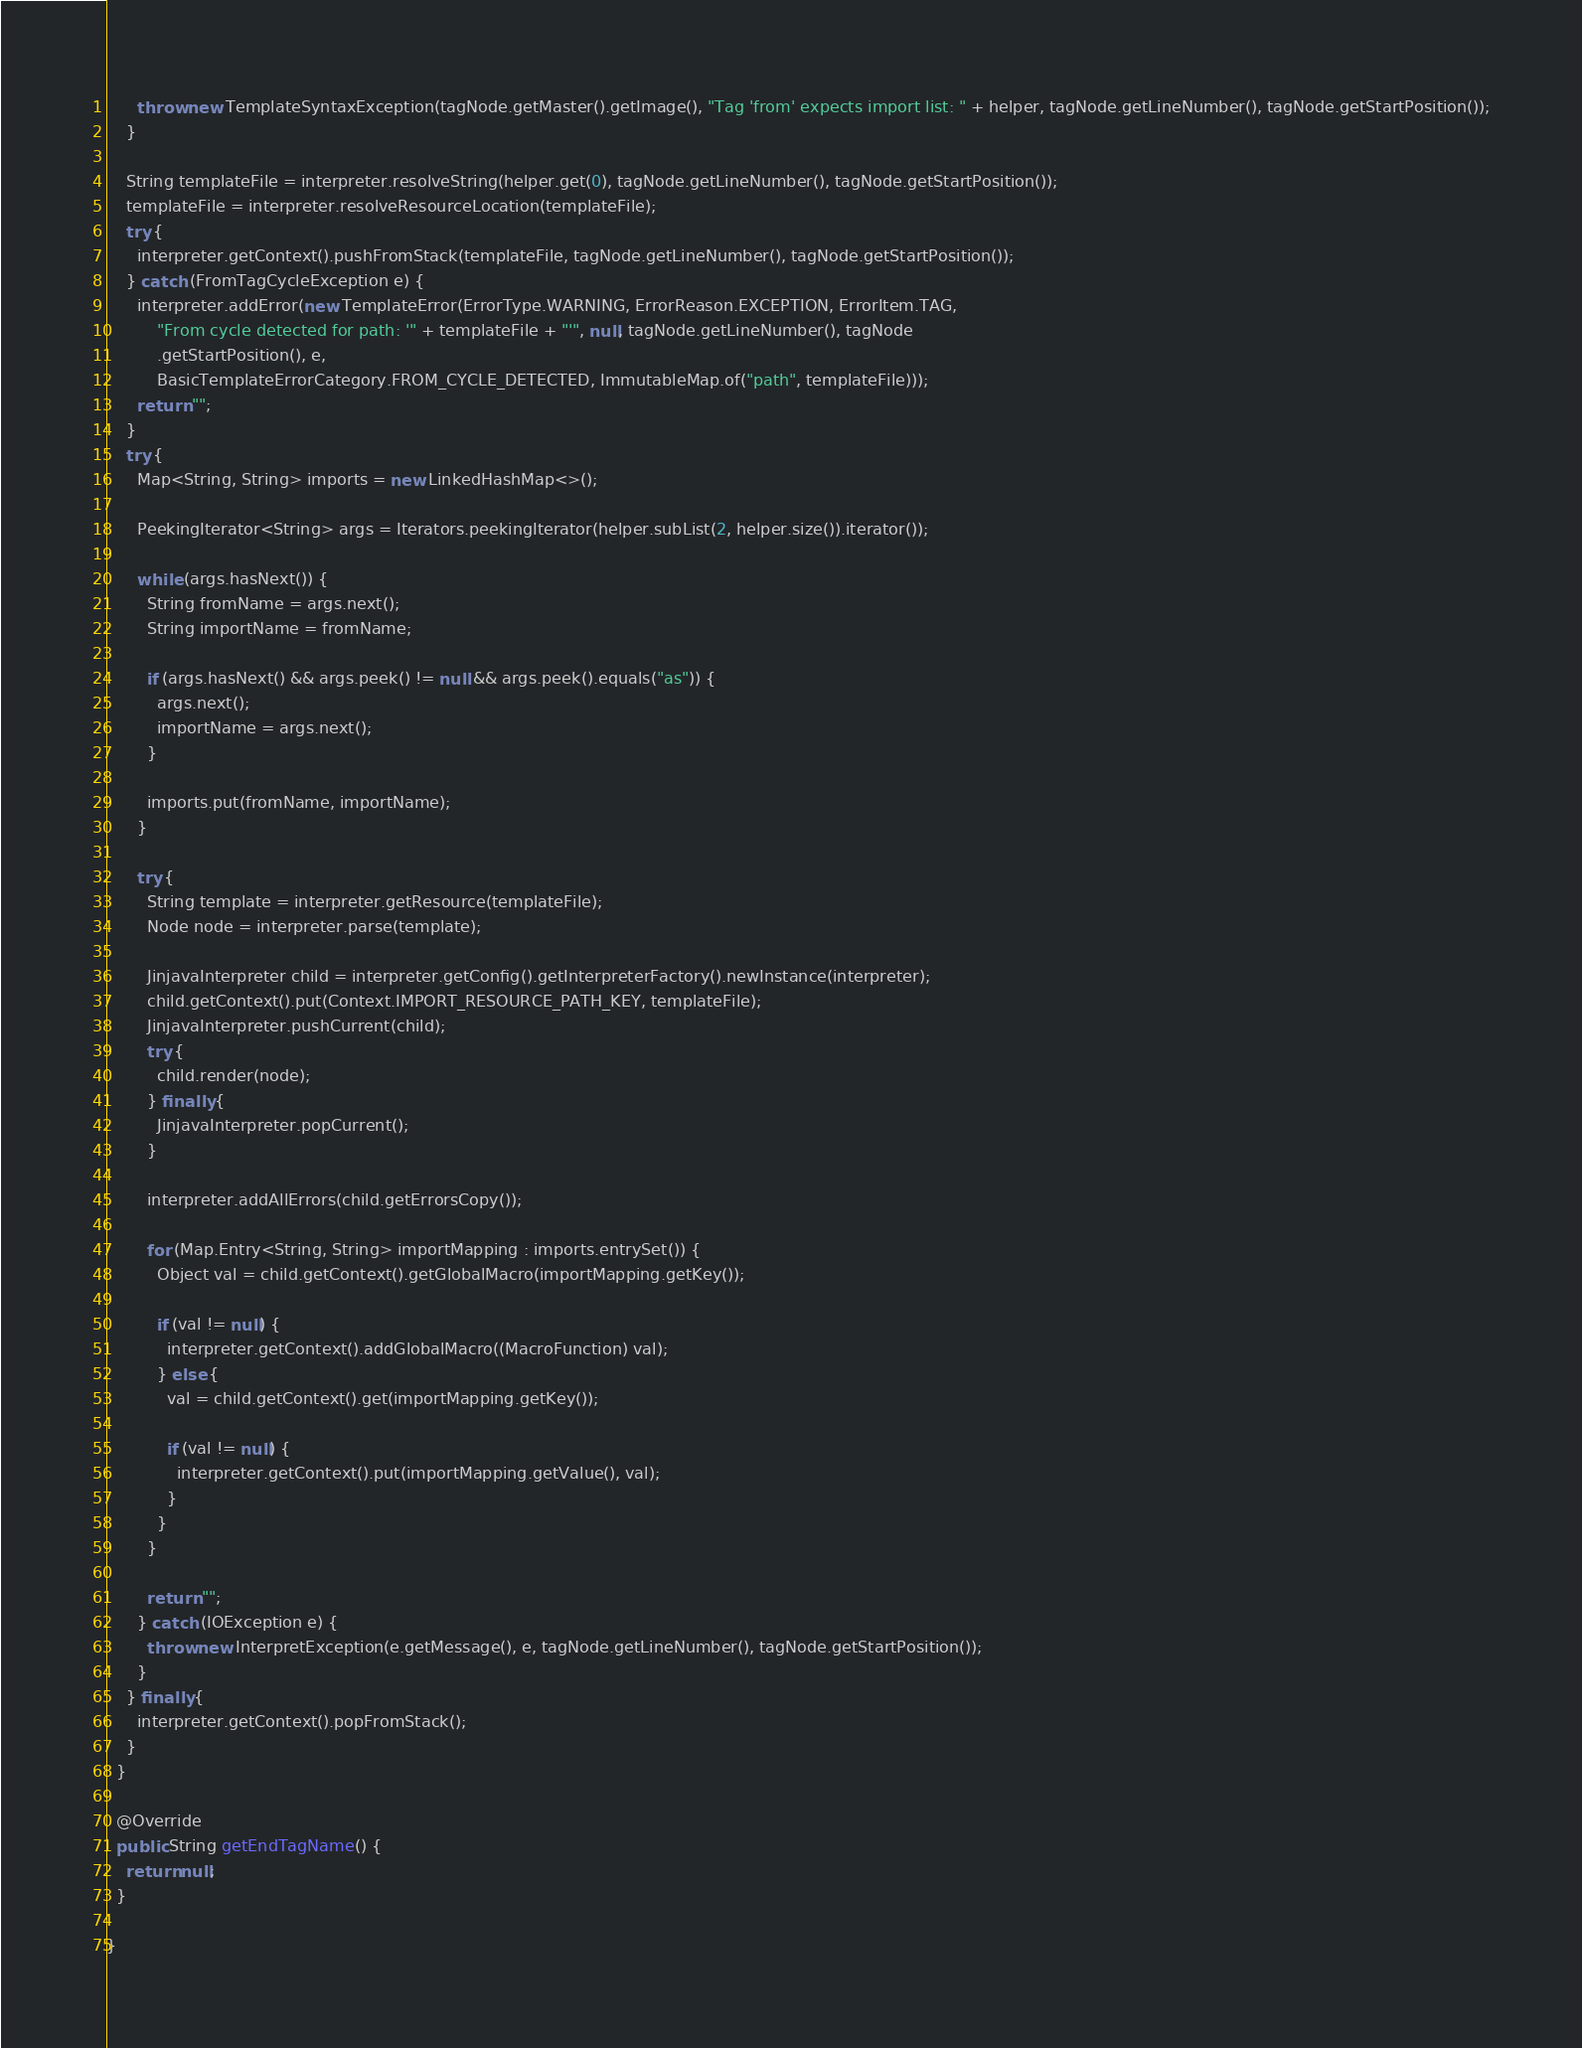<code> <loc_0><loc_0><loc_500><loc_500><_Java_>      throw new TemplateSyntaxException(tagNode.getMaster().getImage(), "Tag 'from' expects import list: " + helper, tagNode.getLineNumber(), tagNode.getStartPosition());
    }

    String templateFile = interpreter.resolveString(helper.get(0), tagNode.getLineNumber(), tagNode.getStartPosition());
    templateFile = interpreter.resolveResourceLocation(templateFile);
    try {
      interpreter.getContext().pushFromStack(templateFile, tagNode.getLineNumber(), tagNode.getStartPosition());
    } catch (FromTagCycleException e) {
      interpreter.addError(new TemplateError(ErrorType.WARNING, ErrorReason.EXCEPTION, ErrorItem.TAG,
          "From cycle detected for path: '" + templateFile + "'", null, tagNode.getLineNumber(), tagNode
          .getStartPosition(), e,
          BasicTemplateErrorCategory.FROM_CYCLE_DETECTED, ImmutableMap.of("path", templateFile)));
      return "";
    }
    try {
      Map<String, String> imports = new LinkedHashMap<>();

      PeekingIterator<String> args = Iterators.peekingIterator(helper.subList(2, helper.size()).iterator());

      while (args.hasNext()) {
        String fromName = args.next();
        String importName = fromName;

        if (args.hasNext() && args.peek() != null && args.peek().equals("as")) {
          args.next();
          importName = args.next();
        }

        imports.put(fromName, importName);
      }

      try {
        String template = interpreter.getResource(templateFile);
        Node node = interpreter.parse(template);

        JinjavaInterpreter child = interpreter.getConfig().getInterpreterFactory().newInstance(interpreter);
        child.getContext().put(Context.IMPORT_RESOURCE_PATH_KEY, templateFile);
        JinjavaInterpreter.pushCurrent(child);
        try {
          child.render(node);
        } finally {
          JinjavaInterpreter.popCurrent();
        }

        interpreter.addAllErrors(child.getErrorsCopy());

        for (Map.Entry<String, String> importMapping : imports.entrySet()) {
          Object val = child.getContext().getGlobalMacro(importMapping.getKey());

          if (val != null) {
            interpreter.getContext().addGlobalMacro((MacroFunction) val);
          } else {
            val = child.getContext().get(importMapping.getKey());

            if (val != null) {
              interpreter.getContext().put(importMapping.getValue(), val);
            }
          }
        }

        return "";
      } catch (IOException e) {
        throw new InterpretException(e.getMessage(), e, tagNode.getLineNumber(), tagNode.getStartPosition());
      }
    } finally {
      interpreter.getContext().popFromStack();
    }
  }

  @Override
  public String getEndTagName() {
    return null;
  }

}
</code> 